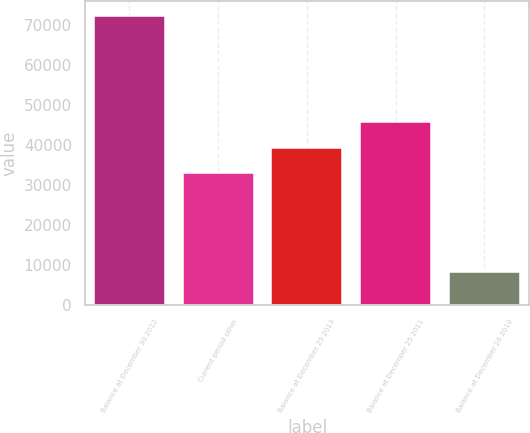<chart> <loc_0><loc_0><loc_500><loc_500><bar_chart><fcel>Balance at December 30 2012<fcel>Current period other<fcel>Balance at December 29 2013<fcel>Balance at December 25 2011<fcel>Balance at December 26 2010<nl><fcel>72307<fcel>32902<fcel>39317.8<fcel>45733.6<fcel>8149<nl></chart> 